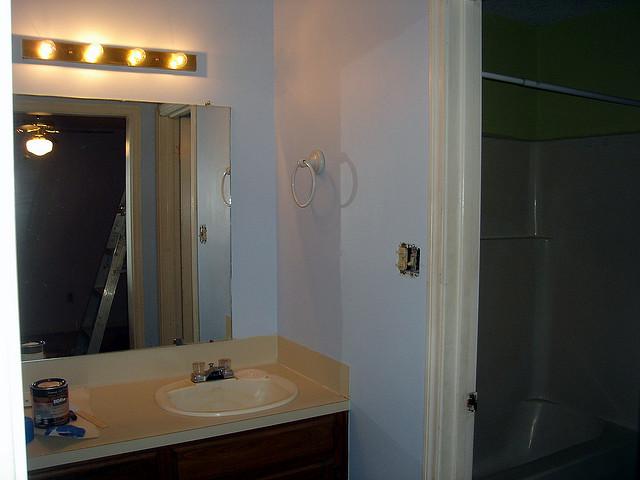What is missing from the light switch?
Concise answer only. Cover. What brand of cleaning supplies are shown?
Give a very brief answer. None. What is gold?
Short answer required. Lights. Is it night time?
Be succinct. Yes. What color is the sink?
Quick response, please. White. What is in reflection?
Be succinct. Light. What common household item is being reflected in the center of the mirror?
Answer briefly. Light. How many lights are above the mirror?
Keep it brief. 4. How many lights are on?
Write a very short answer. 5. How many sinks are in the picture?
Give a very brief answer. 1. 